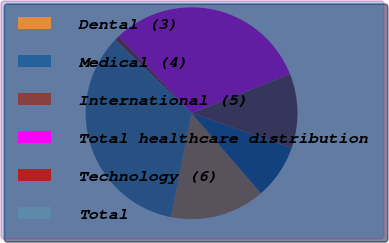<chart> <loc_0><loc_0><loc_500><loc_500><pie_chart><fcel>Dental (3)<fcel>Medical (4)<fcel>International (5)<fcel>Total healthcare distribution<fcel>Technology (6)<fcel>Total<nl><fcel>14.49%<fcel>8.29%<fcel>11.39%<fcel>31.0%<fcel>0.71%<fcel>34.1%<nl></chart> 